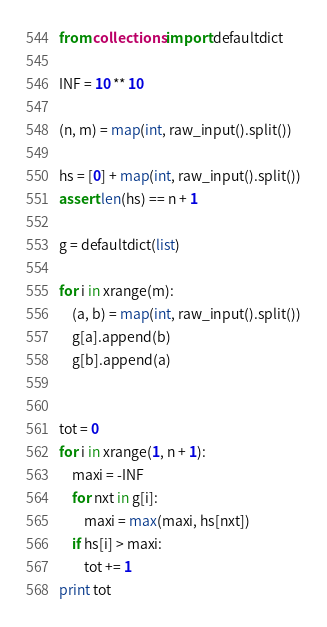<code> <loc_0><loc_0><loc_500><loc_500><_Python_>from collections import defaultdict

INF = 10 ** 10

(n, m) = map(int, raw_input().split())

hs = [0] + map(int, raw_input().split())
assert len(hs) == n + 1

g = defaultdict(list)

for i in xrange(m):
    (a, b) = map(int, raw_input().split())
    g[a].append(b)
    g[b].append(a)


tot = 0
for i in xrange(1, n + 1):
    maxi = -INF
    for nxt in g[i]:
        maxi = max(maxi, hs[nxt])
    if hs[i] > maxi:
        tot += 1
print tot
</code> 